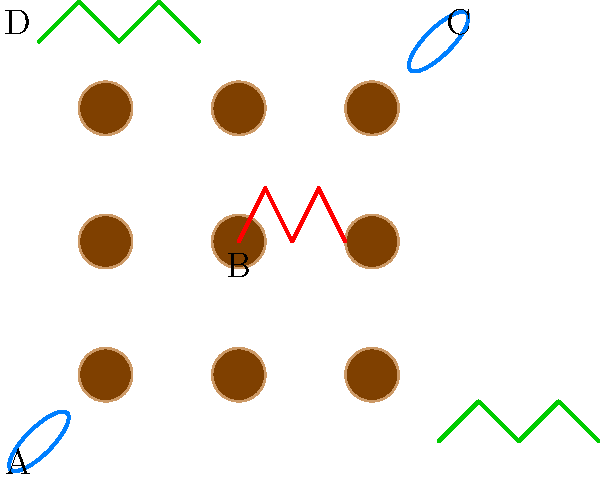Match the following Indonesian batik patterns with themes from translated Indonesian literature:

1. Kawung (circular pattern)
2. Parang (diagonal lines)
3. Mega Mendung (cloud-like pattern)
4. Buketan (floral pattern)

A) Conflict and struggle
B) Harmony and balance
C) Nature and environment
D) Tradition and modernity

Which pattern-theme pair best represents the central motif in Pramoedya Ananta Toer's "This Earth of Mankind"? To answer this question, we need to analyze the batik patterns and their symbolic meanings, and then relate them to the themes in Pramoedya Ananta Toer's "This Earth of Mankind":

1. Kawung (B): Circular pattern symbolizing harmony and balance.
2. Parang (A): Diagonal lines representing conflict and struggle.
3. Mega Mendung (C): Cloud-like pattern symbolizing nature and environment.
4. Buketan (D): Floral pattern representing the blend of tradition and modernity.

Now, let's consider the central themes in "This Earth of Mankind":

1. The novel is set during the Dutch colonial period in Indonesia.
2. It explores the conflict between traditional Javanese culture and modern European influences.
3. The protagonist, Minke, struggles to reconcile his native heritage with his European education.
4. The story highlights the tension between old customs and new ideas.

Given these themes, the batik pattern that best represents the central motif in the novel is the Parang pattern (A), symbolizing conflict and struggle. This pattern aligns with the protagonist's internal conflict and the broader societal tensions depicted in the novel.
Answer: Parang (conflict and struggle) 